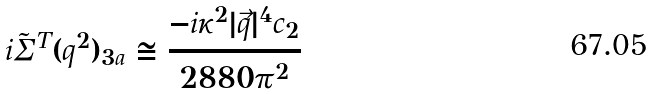Convert formula to latex. <formula><loc_0><loc_0><loc_500><loc_500>i \tilde { \Sigma } ^ { T } ( q ^ { 2 } ) _ { 3 a } \cong \frac { - i \kappa ^ { 2 } | \vec { q } | ^ { 4 } c _ { 2 } } { 2 8 8 0 \pi ^ { 2 } }</formula> 